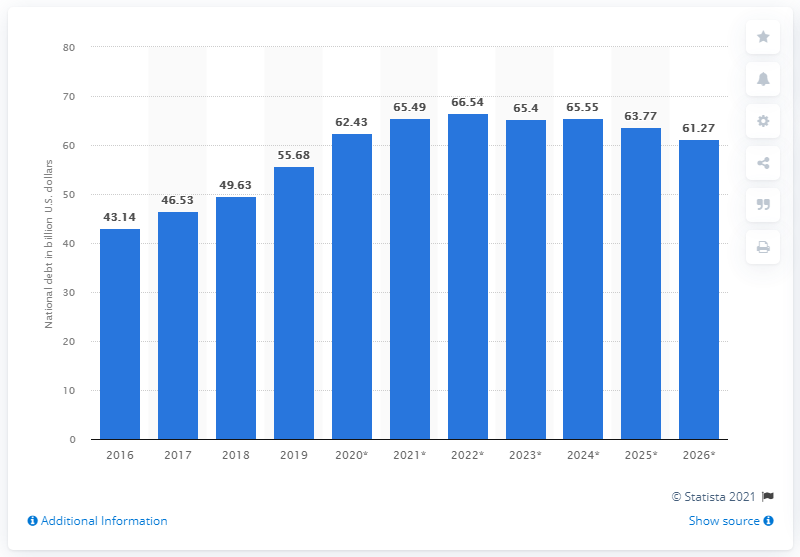Specify some key components in this picture. In 2019, Ecuador's national debt was 55.68 dollars. 